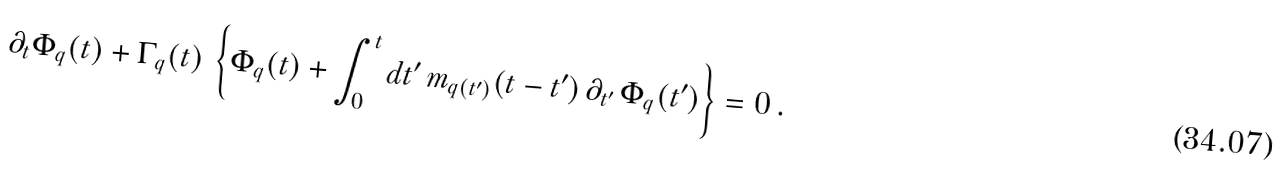Convert formula to latex. <formula><loc_0><loc_0><loc_500><loc_500>\partial _ { t } \Phi _ { q } ( t ) + \Gamma _ { q } ( t ) \, \left \{ \Phi _ { q } ( t ) + \int _ { 0 } ^ { t } d t ^ { \prime } \, m _ { { q } ( t ^ { \prime } ) } ( t - t ^ { \prime } ) \, \partial _ { t ^ { \prime } } \, \Phi _ { q } ( t ^ { \prime } ) \right \} = 0 \, .</formula> 